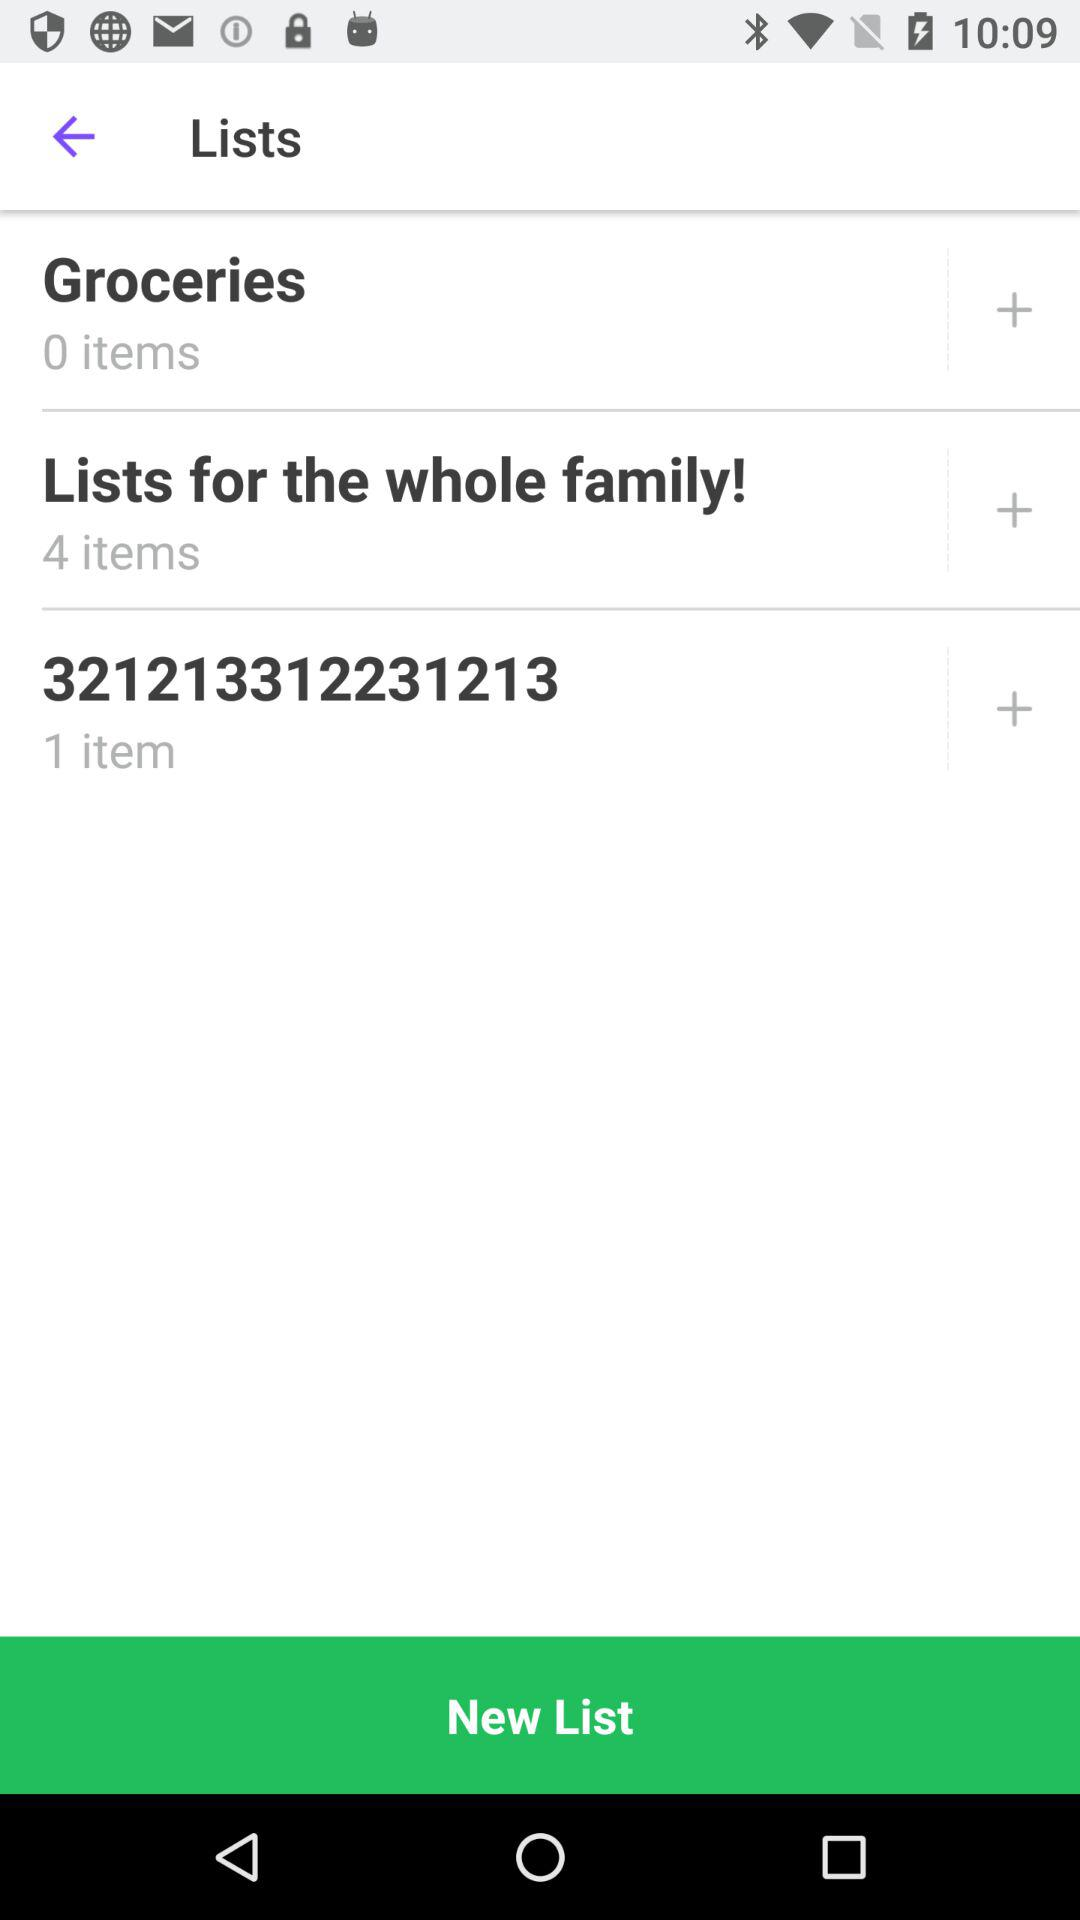How many items are there in the grocery list? There are 0 items in the grocery list. 